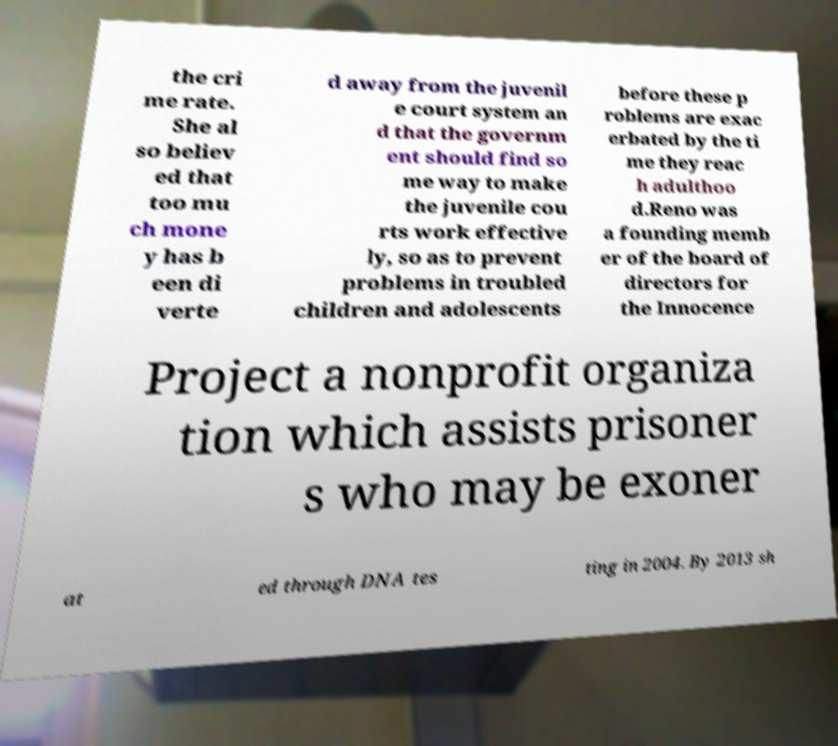I need the written content from this picture converted into text. Can you do that? the cri me rate. She al so believ ed that too mu ch mone y has b een di verte d away from the juvenil e court system an d that the governm ent should find so me way to make the juvenile cou rts work effective ly, so as to prevent problems in troubled children and adolescents before these p roblems are exac erbated by the ti me they reac h adulthoo d.Reno was a founding memb er of the board of directors for the Innocence Project a nonprofit organiza tion which assists prisoner s who may be exoner at ed through DNA tes ting in 2004. By 2013 sh 